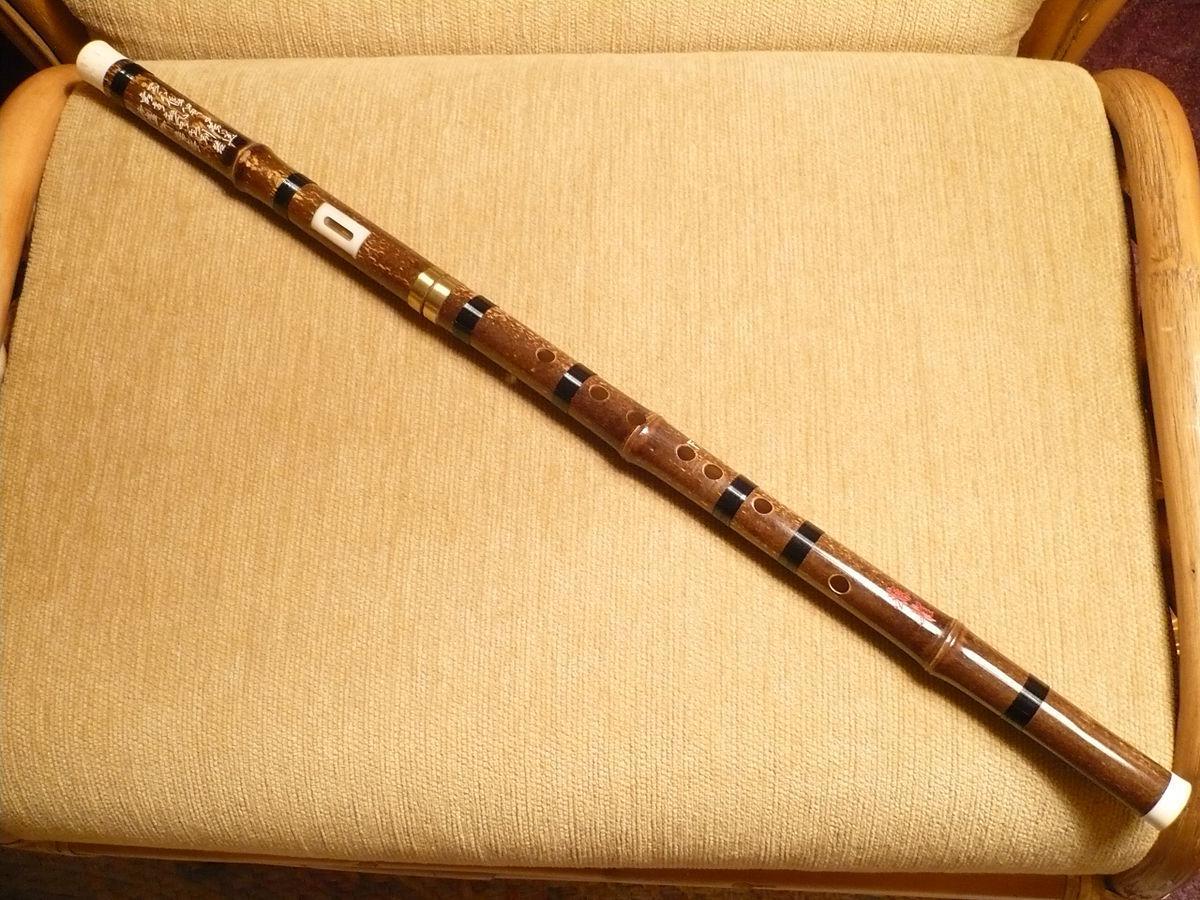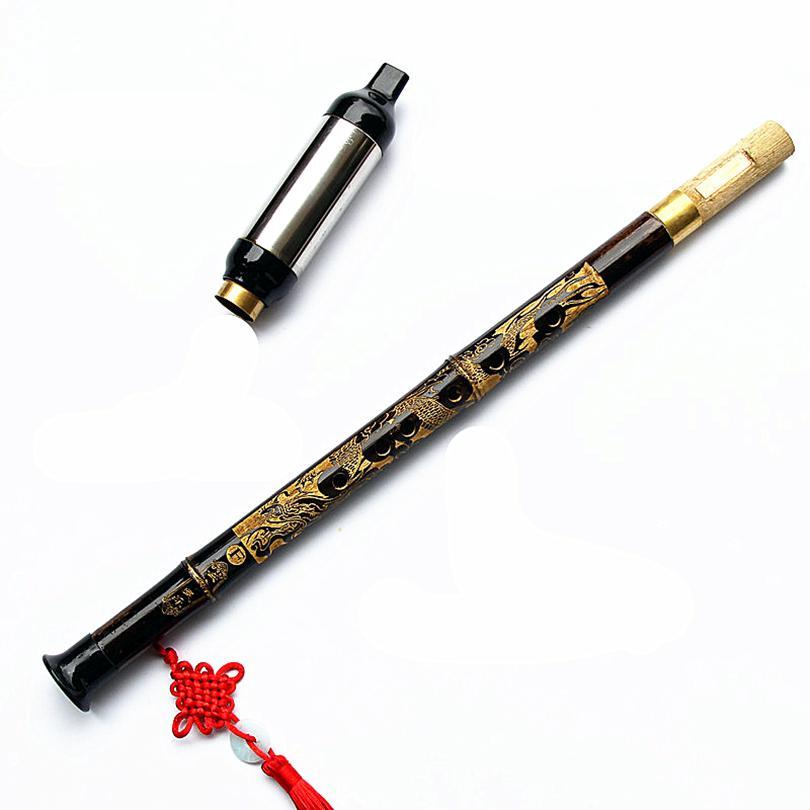The first image is the image on the left, the second image is the image on the right. Given the left and right images, does the statement "there is a flute with a red tassel hanging from the lower half and a soft fabric pouch next to it" hold true? Answer yes or no. No. 